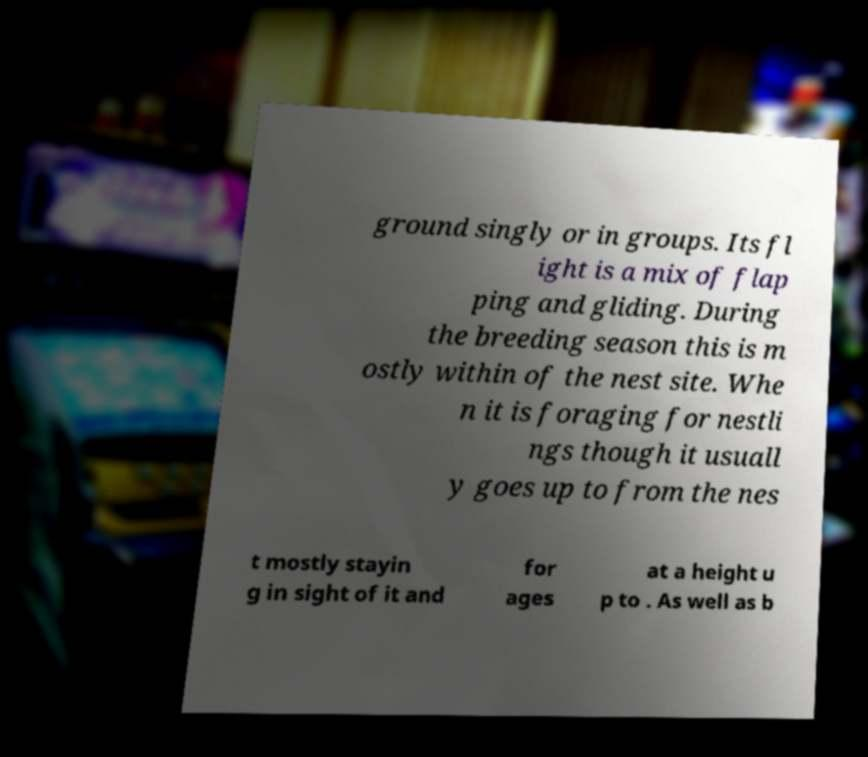I need the written content from this picture converted into text. Can you do that? ground singly or in groups. Its fl ight is a mix of flap ping and gliding. During the breeding season this is m ostly within of the nest site. Whe n it is foraging for nestli ngs though it usuall y goes up to from the nes t mostly stayin g in sight of it and for ages at a height u p to . As well as b 